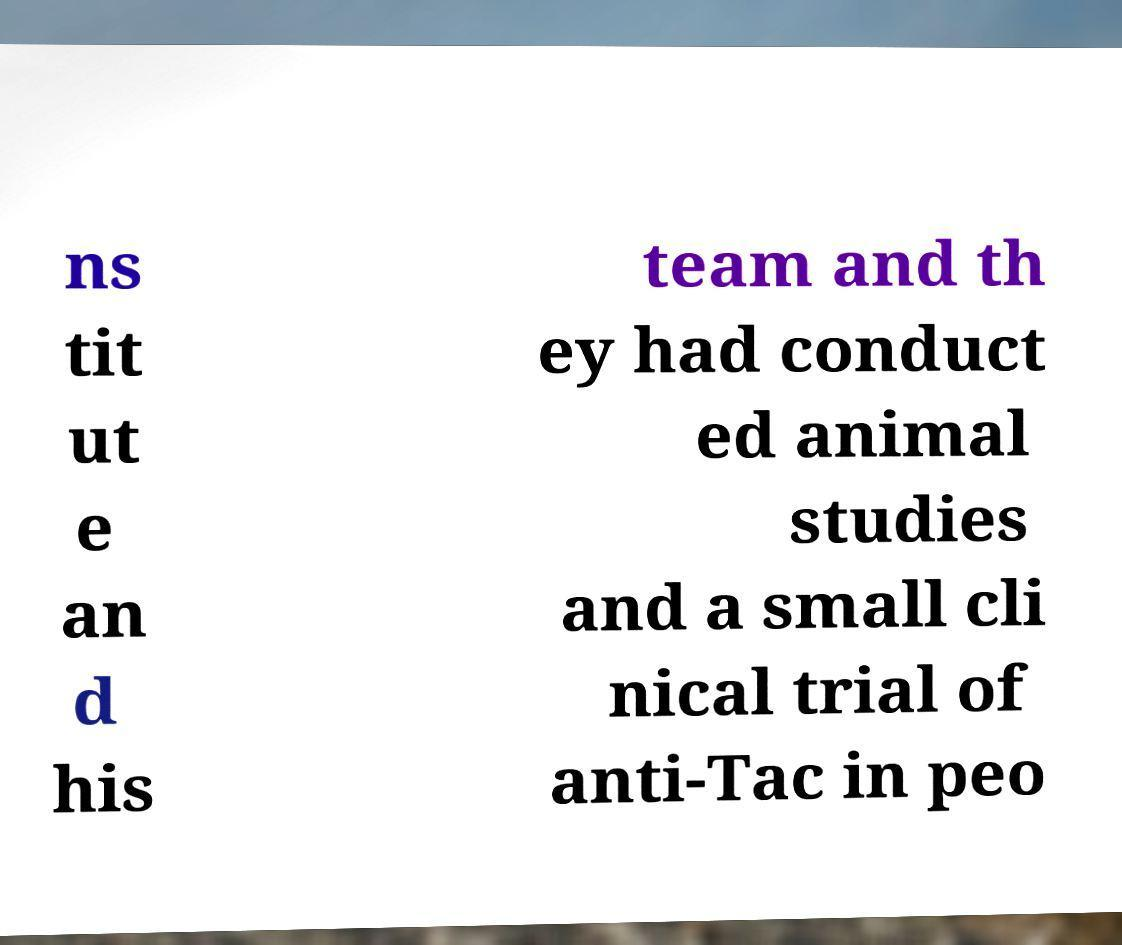There's text embedded in this image that I need extracted. Can you transcribe it verbatim? ns tit ut e an d his team and th ey had conduct ed animal studies and a small cli nical trial of anti-Tac in peo 